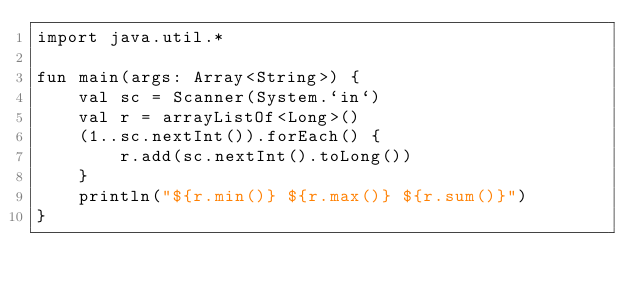<code> <loc_0><loc_0><loc_500><loc_500><_Kotlin_>import java.util.*

fun main(args: Array<String>) {
    val sc = Scanner(System.`in`)
    val r = arrayListOf<Long>()
    (1..sc.nextInt()).forEach() {
        r.add(sc.nextInt().toLong())
    }
    println("${r.min()} ${r.max()} ${r.sum()}")
}

</code> 